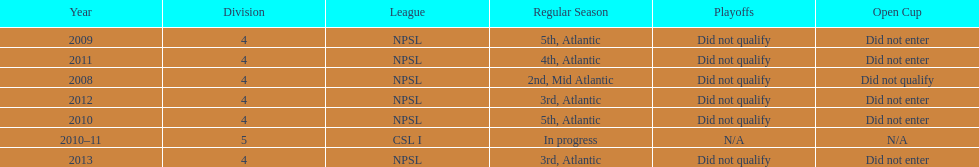Using the data, what should be the next year they will play? 2014. 